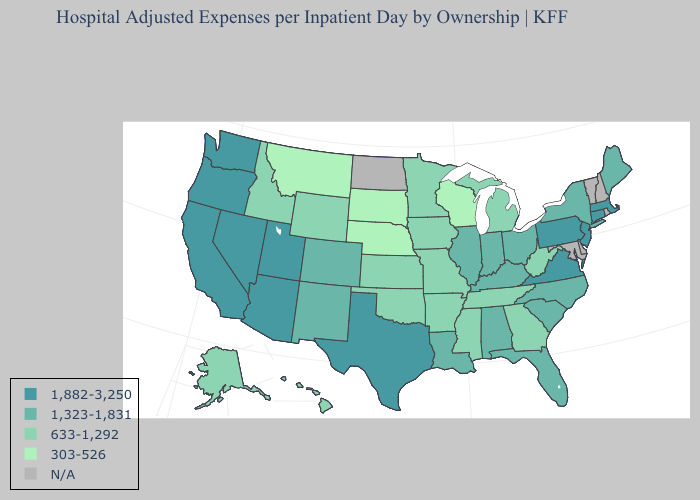Is the legend a continuous bar?
Quick response, please. No. Name the states that have a value in the range 303-526?
Concise answer only. Montana, Nebraska, South Dakota, Wisconsin. Among the states that border New Hampshire , does Massachusetts have the lowest value?
Concise answer only. No. What is the lowest value in states that border Colorado?
Quick response, please. 303-526. What is the value of Mississippi?
Keep it brief. 633-1,292. What is the value of Virginia?
Concise answer only. 1,882-3,250. Among the states that border New Mexico , which have the lowest value?
Concise answer only. Oklahoma. What is the value of Wyoming?
Write a very short answer. 633-1,292. Does the map have missing data?
Quick response, please. Yes. What is the value of Utah?
Concise answer only. 1,882-3,250. What is the value of Arizona?
Answer briefly. 1,882-3,250. Name the states that have a value in the range 633-1,292?
Answer briefly. Alaska, Arkansas, Georgia, Hawaii, Idaho, Iowa, Kansas, Michigan, Minnesota, Mississippi, Missouri, Oklahoma, Tennessee, West Virginia, Wyoming. Does the first symbol in the legend represent the smallest category?
Be succinct. No. Among the states that border Louisiana , which have the highest value?
Write a very short answer. Texas. 